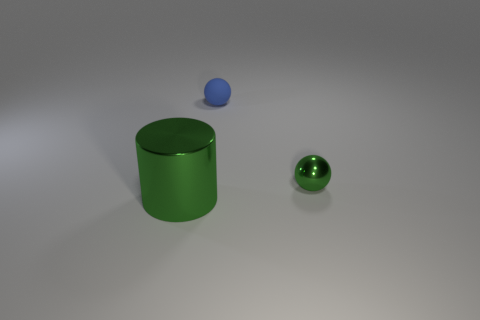Is there anything else that has the same color as the small shiny object?
Give a very brief answer. Yes. How many things are either cylinders or tiny shiny balls?
Provide a succinct answer. 2. Does the metallic object that is right of the cylinder have the same size as the tiny rubber thing?
Give a very brief answer. Yes. How many other things are there of the same size as the metal cylinder?
Offer a terse response. 0. Are any small red cylinders visible?
Keep it short and to the point. No. There is a sphere that is to the left of the small ball that is to the right of the blue rubber object; how big is it?
Your answer should be compact. Small. There is a metal object left of the blue matte ball; is its color the same as the shiny thing that is behind the large cylinder?
Offer a very short reply. Yes. What is the color of the thing that is in front of the blue matte thing and left of the tiny metal object?
Make the answer very short. Green. What number of other things are there of the same shape as the big green object?
Your response must be concise. 0. The metallic ball that is the same size as the blue matte ball is what color?
Your answer should be very brief. Green. 